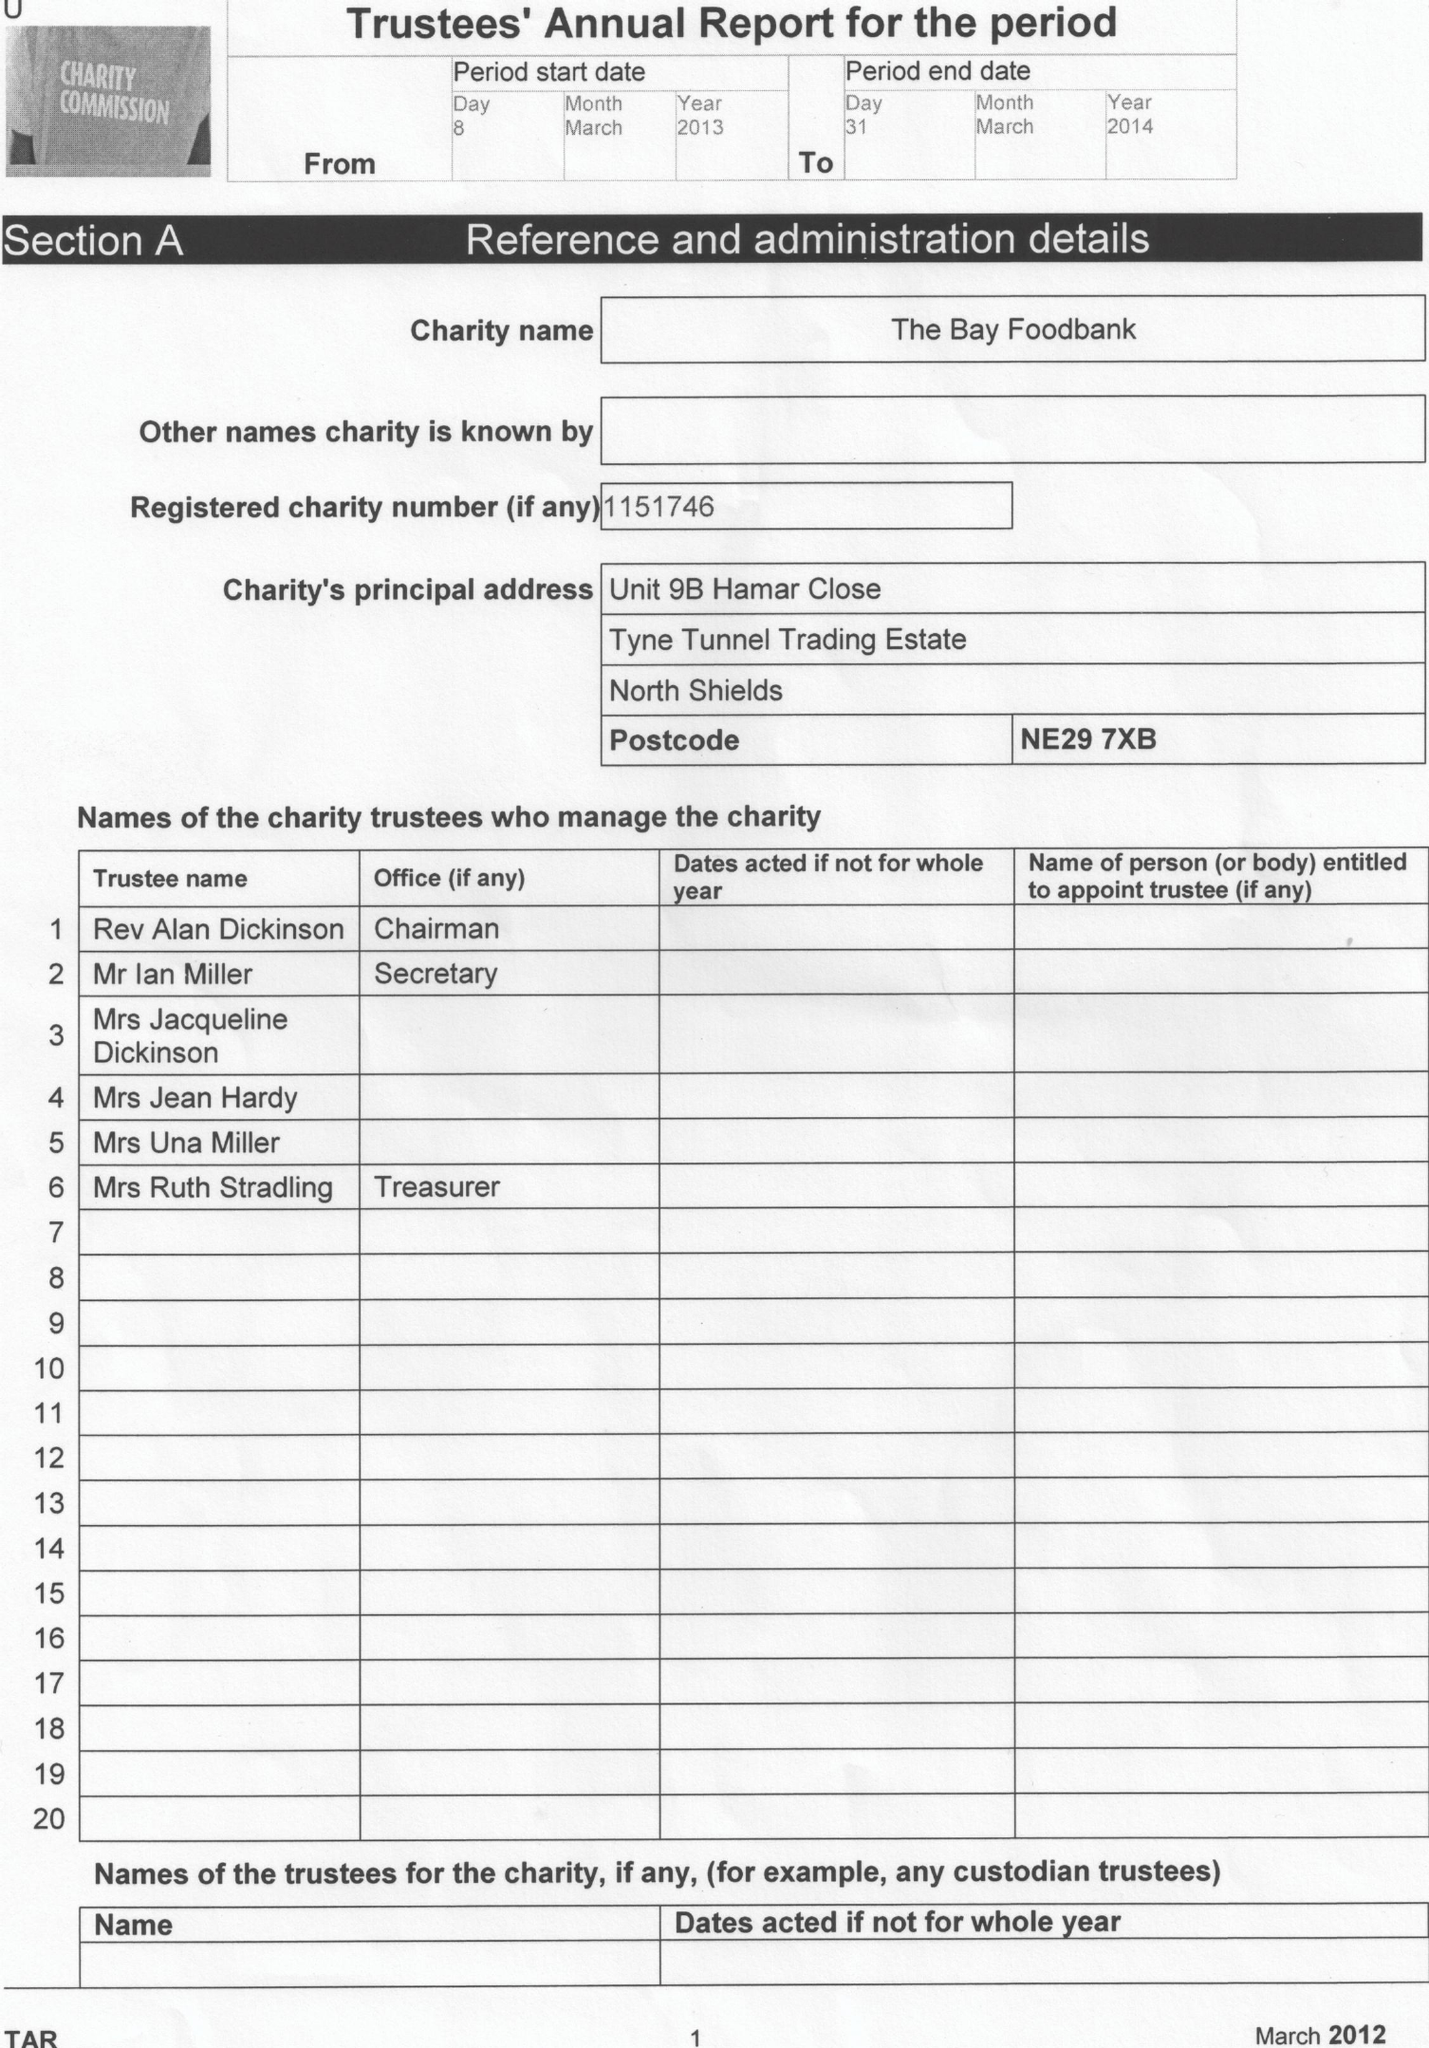What is the value for the charity_number?
Answer the question using a single word or phrase. 1151746 